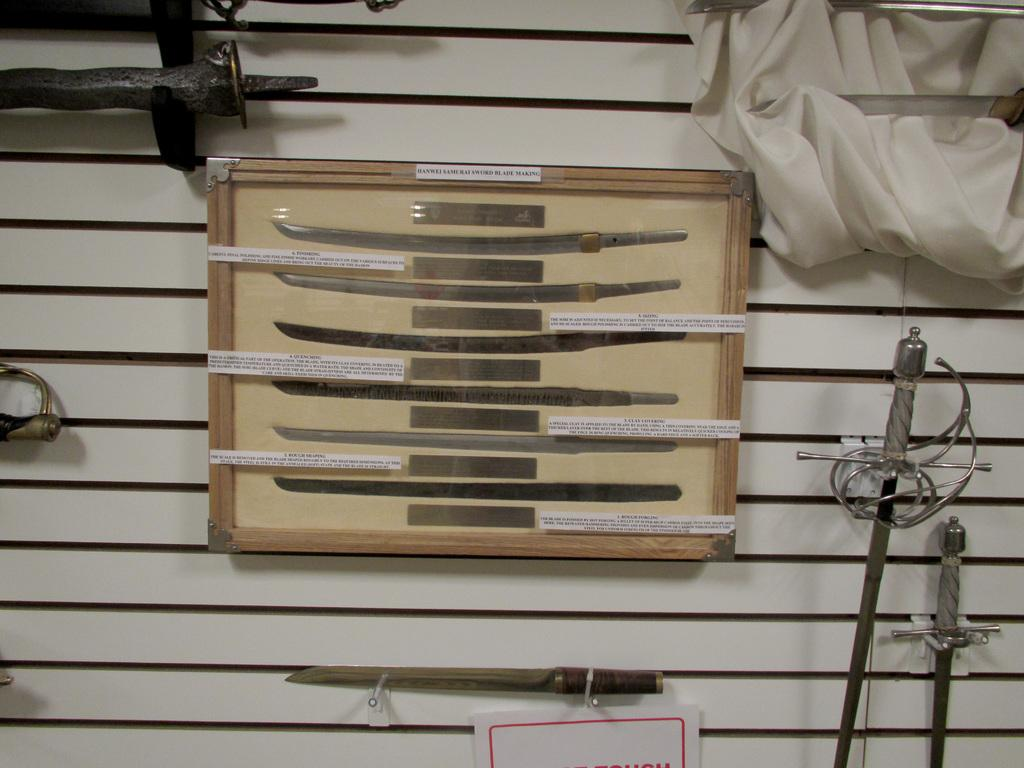What is inside the box that is visible in the image? There are tools inside a box in the image. Where is the box located in the image? The box is placed on a surface in the image. What other items can be seen related to cutting or slicing in the image? There are knives with a stand in the image. What type of material is present for cleaning or wiping in the image? There is a cloth in the image for cleaning or wiping. What is attached to the surface in the image? There is a paper pasted on the surface in the image. Who is the manager of the tools in the image? There is no manager present in the image; it is a still image of tools and other items. What type of toothbrush is used for cleaning the tools in the image? There is no toothbrush present in the image, and toothbrushes are not used for cleaning tools. 